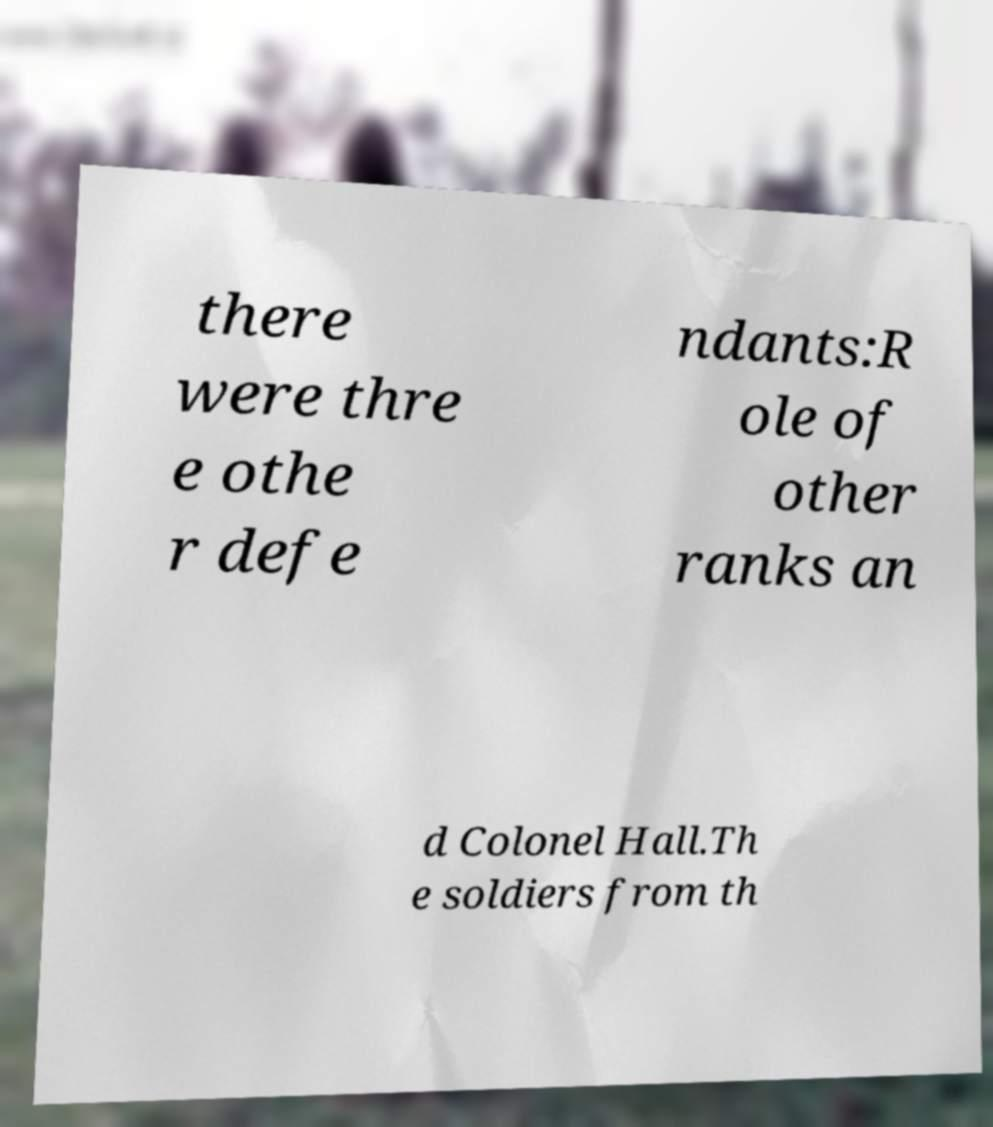Please read and relay the text visible in this image. What does it say? there were thre e othe r defe ndants:R ole of other ranks an d Colonel Hall.Th e soldiers from th 